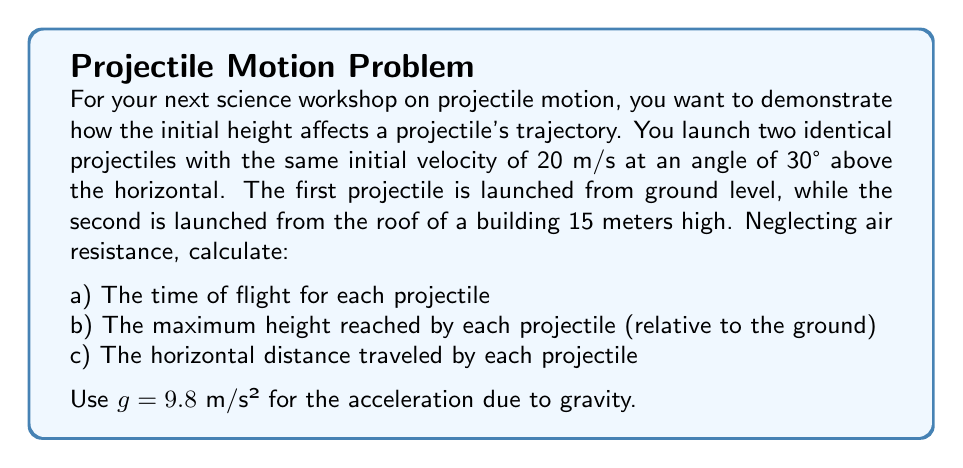Can you solve this math problem? Let's solve this problem step by step for both projectiles:

1) First, let's recall the relevant equations:
   $$v_x = v_0 \cos \theta$$
   $$v_y = v_0 \sin \theta - gt$$
   $$x = v_0 \cos \theta \cdot t$$
   $$y = h_0 + v_0 \sin \theta \cdot t - \frac{1}{2}gt^2$$

   Where $v_0$ is the initial velocity, $\theta$ is the launch angle, $g$ is the acceleration due to gravity, $t$ is time, and $h_0$ is the initial height.

2) Given:
   $v_0 = 20$ m/s
   $\theta = 30°$
   $g = 9.8$ m/s²
   $h_0 = 0$ m (for projectile 1)
   $h_0 = 15$ m (for projectile 2)

3) Let's calculate the components of the initial velocity:
   $$v_x = 20 \cos 30° = 17.32 \text{ m/s}$$
   $$v_y = 20 \sin 30° = 10 \text{ m/s}$$

a) Time of flight:
   For projectile 1 (ground level):
   At the highest point, $v_y = 0$
   $$0 = 10 - 9.8t$$
   $$t_{up} = 1.02 \text{ s}$$
   Total time of flight = $2 \cdot 1.02 = 2.04 \text{ s}$

   For projectile 2 (15 m high):
   At landing, $y = 0$
   $$0 = 15 + 10t - 4.9t^2$$
   Solving this quadratic equation:
   $$t = 2.55 \text{ s}$$

b) Maximum height:
   For projectile 1:
   $$h_{max} = 0 + 10 \cdot 1.02 - \frac{1}{2} \cdot 9.8 \cdot 1.02^2 = 5.1 \text{ m}$$

   For projectile 2:
   $$h_{max} = 15 + 10 \cdot 1.28 - \frac{1}{2} \cdot 9.8 \cdot 1.28^2 = 20.1 \text{ m}$$
   (Where 1.28 s is half the total flight time)

c) Horizontal distance:
   For projectile 1:
   $$x = 17.32 \cdot 2.04 = 35.33 \text{ m}$$

   For projectile 2:
   $$x = 17.32 \cdot 2.55 = 44.17 \text{ m}$$
Answer: a) Time of flight:
   Projectile 1: 2.04 s
   Projectile 2: 2.55 s

b) Maximum height (relative to ground):
   Projectile 1: 5.1 m
   Projectile 2: 20.1 m

c) Horizontal distance:
   Projectile 1: 35.33 m
   Projectile 2: 44.17 m 